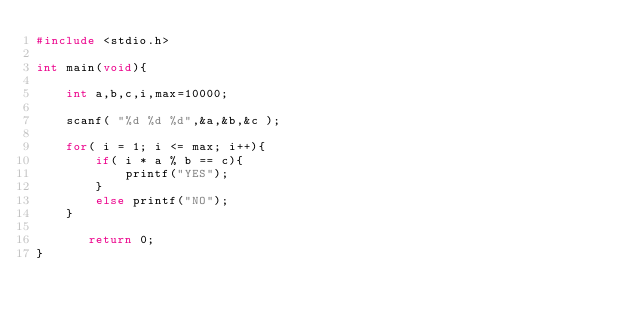Convert code to text. <code><loc_0><loc_0><loc_500><loc_500><_C_>#include <stdio.h>

int main(void){
    
    int a,b,c,i,max=10000;
    
    scanf( "%d %d %d",&a,&b,&c );
    
    for( i = 1; i <= max; i++){
        if( i * a % b == c){
            printf("YES");
        }
        else printf("NO");
    }

       return 0;
}</code> 